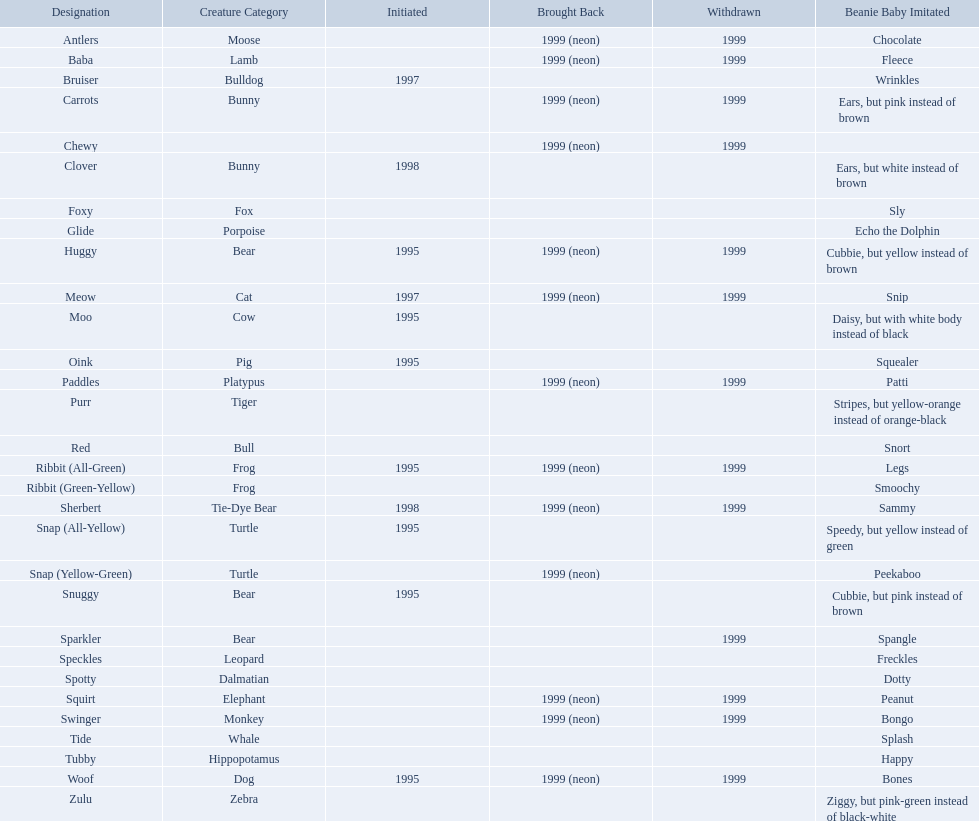What are the types of pillow pal animals? Antlers, Moose, Lamb, Bulldog, Bunny, , Bunny, Fox, Porpoise, Bear, Cat, Cow, Pig, Platypus, Tiger, Bull, Frog, Frog, Tie-Dye Bear, Turtle, Turtle, Bear, Bear, Leopard, Dalmatian, Elephant, Monkey, Whale, Hippopotamus, Dog, Zebra. Of those, which is a dalmatian? Dalmatian. What is the name of the dalmatian? Spotty. What are all the different names of the pillow pals? Antlers, Baba, Bruiser, Carrots, Chewy, Clover, Foxy, Glide, Huggy, Meow, Moo, Oink, Paddles, Purr, Red, Ribbit (All-Green), Ribbit (Green-Yellow), Sherbert, Snap (All-Yellow), Snap (Yellow-Green), Snuggy, Sparkler, Speckles, Spotty, Squirt, Swinger, Tide, Tubby, Woof, Zulu. Which of these are a dalmatian? Spotty. What are the names listed? Antlers, Baba, Bruiser, Carrots, Chewy, Clover, Foxy, Glide, Huggy, Meow, Moo, Oink, Paddles, Purr, Red, Ribbit (All-Green), Ribbit (Green-Yellow), Sherbert, Snap (All-Yellow), Snap (Yellow-Green), Snuggy, Sparkler, Speckles, Spotty, Squirt, Swinger, Tide, Tubby, Woof, Zulu. Of these, which is the only pet without an animal type listed? Chewy. 